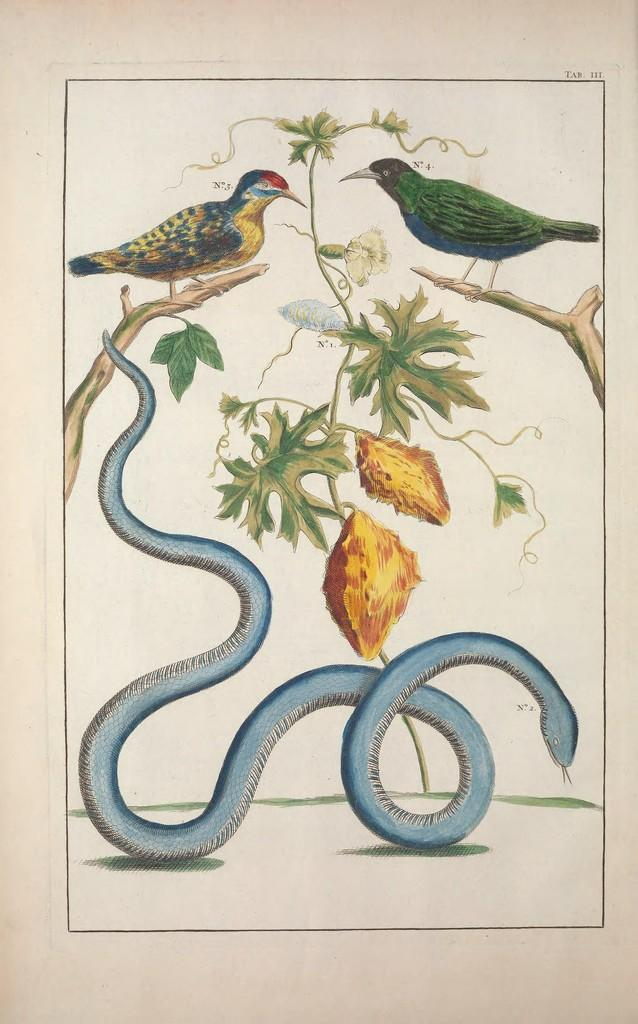What is depicted on the poster in the image? The poster contains a snake and plants. Are there any animals on the poster besides the snake? Yes, there are two birds on the stem in the poster. Where is the text located on the poster? The text is in the top right corner of the poster. What type of information is included in the top right corner of the poster? There are numerical numbers in the top right corner of the poster. What type of ear is visible on the snake in the image? There is no ear visible on the snake in the image, as snakes do not have ears. 